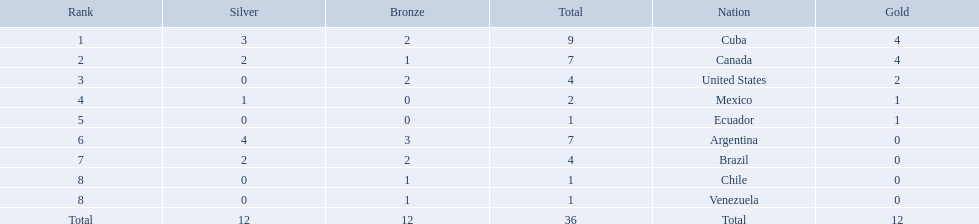What were all of the nations involved in the canoeing at the 2011 pan american games? Cuba, Canada, United States, Mexico, Ecuador, Argentina, Brazil, Chile, Venezuela, Total. Of these, which had a numbered rank? Cuba, Canada, United States, Mexico, Ecuador, Argentina, Brazil, Chile, Venezuela. From these, which had the highest number of bronze? Argentina. 